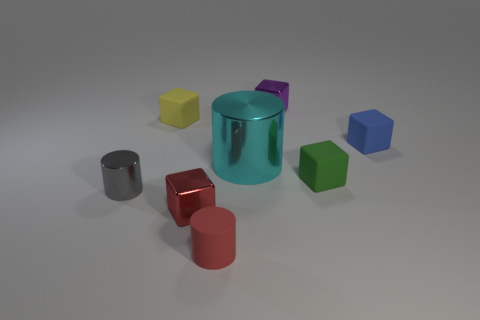Is the size of the rubber block to the left of the purple metal thing the same as the purple object?
Make the answer very short. Yes. Does the blue cube behind the large cylinder have the same material as the cylinder behind the small gray thing?
Give a very brief answer. No. Are there any red metallic things of the same size as the gray thing?
Your answer should be compact. Yes. There is a tiny red thing in front of the tiny red object that is behind the small cylinder in front of the gray cylinder; what is its shape?
Give a very brief answer. Cylinder. Is the number of big shiny cylinders on the left side of the cyan object greater than the number of small metal cubes?
Make the answer very short. No. Are there any gray shiny objects that have the same shape as the blue matte thing?
Offer a terse response. No. Does the small gray cylinder have the same material as the green thing that is in front of the big cyan metal cylinder?
Provide a short and direct response. No. The small rubber cylinder has what color?
Your response must be concise. Red. There is a tiny cylinder that is on the right side of the tiny matte thing behind the tiny blue cube; what number of large cylinders are left of it?
Your response must be concise. 0. Are there any tiny cubes right of the big cyan cylinder?
Your answer should be very brief. Yes. 